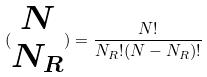Convert formula to latex. <formula><loc_0><loc_0><loc_500><loc_500>( \begin{matrix} N \\ N _ { R } \end{matrix} ) = \frac { N ! } { N _ { R } ! ( N - N _ { R } ) ! }</formula> 